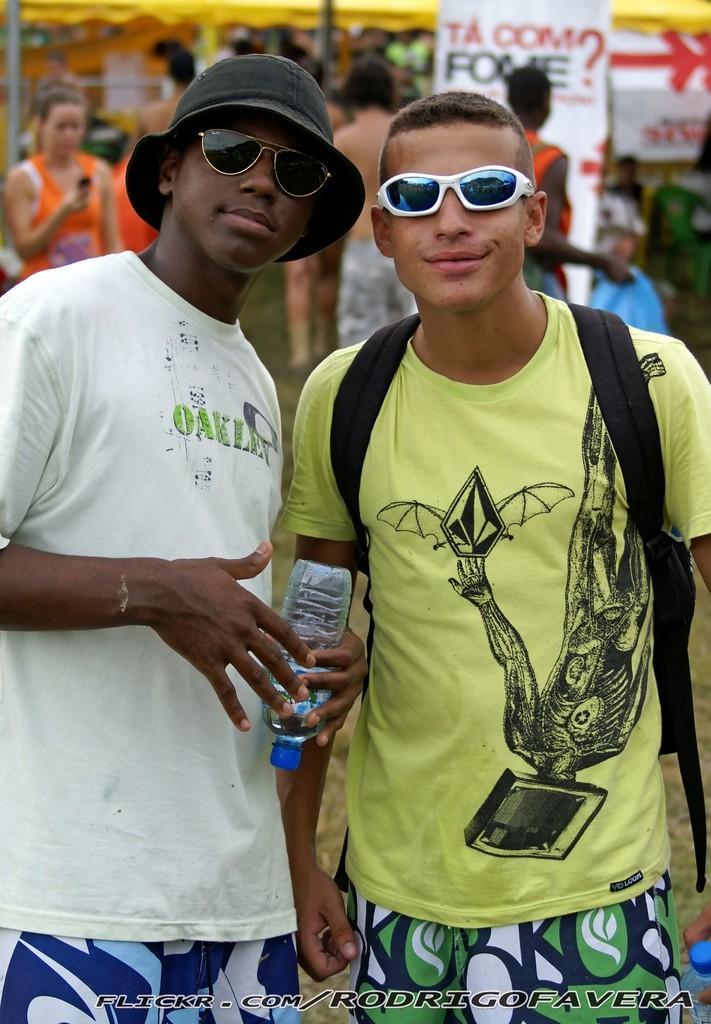Could you give a brief overview of what you see in this image? There are two persons standing as we can see in the middle of this image. The person standing on the left side is holding a bottle. We can see a watermark at the bottom of this image. There are people present in the background. 